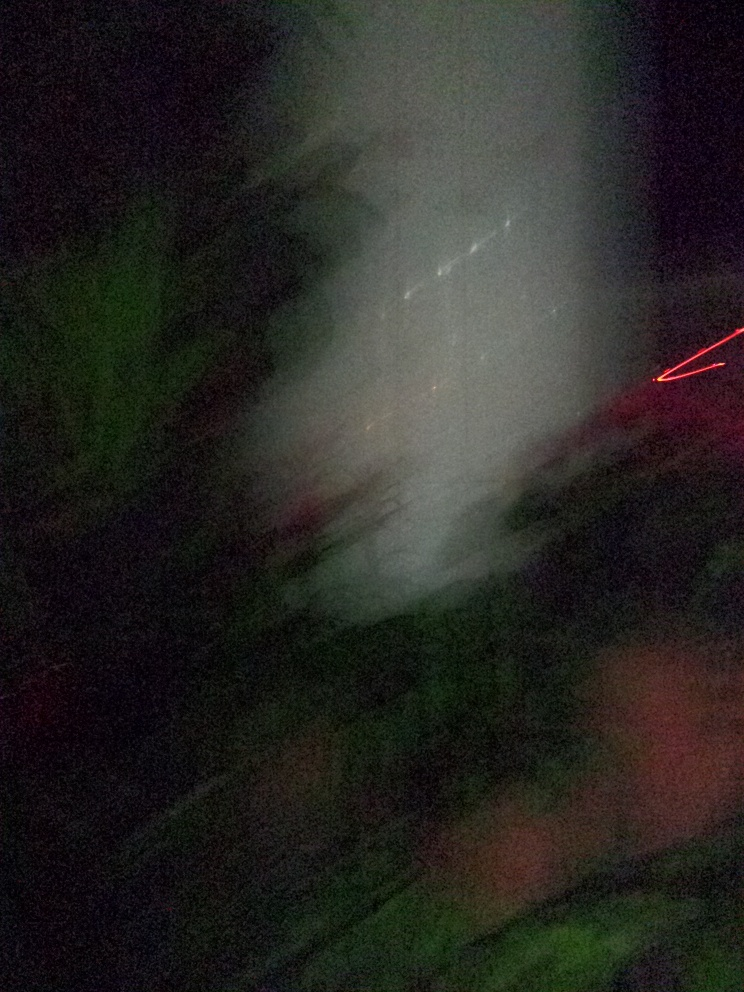Can you suggest some conditions under which this photo might have been taken? This photo might have been taken under low-light conditions with a handheld camera, leading to blur due to camera shake or the subject's movement. It also could have been taken while the photographer was in motion, such as walking or riding in a vehicle. Another possibility is that it's an intentional artistic shot aimed at capturing an abstract or impressionistic scene, where the focus is on the play of light and color rather than on clear subjects. 